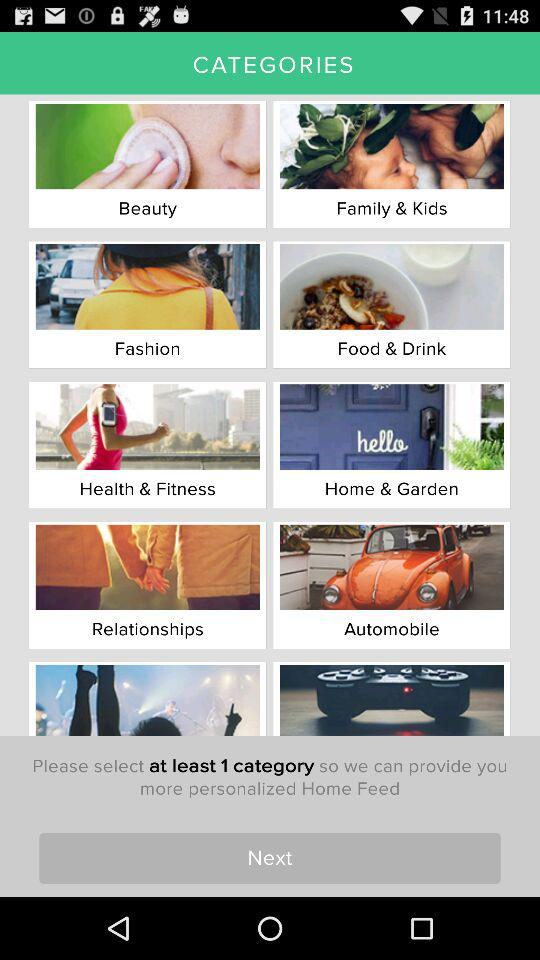What are the names of the different categories shown on the screen? The names of the different categories are "Beauty", "Family & Kids", "Fashion", "Food & Drink", "Health & Fitness", "Home & Garden", "Relationships" and "Automobile". 